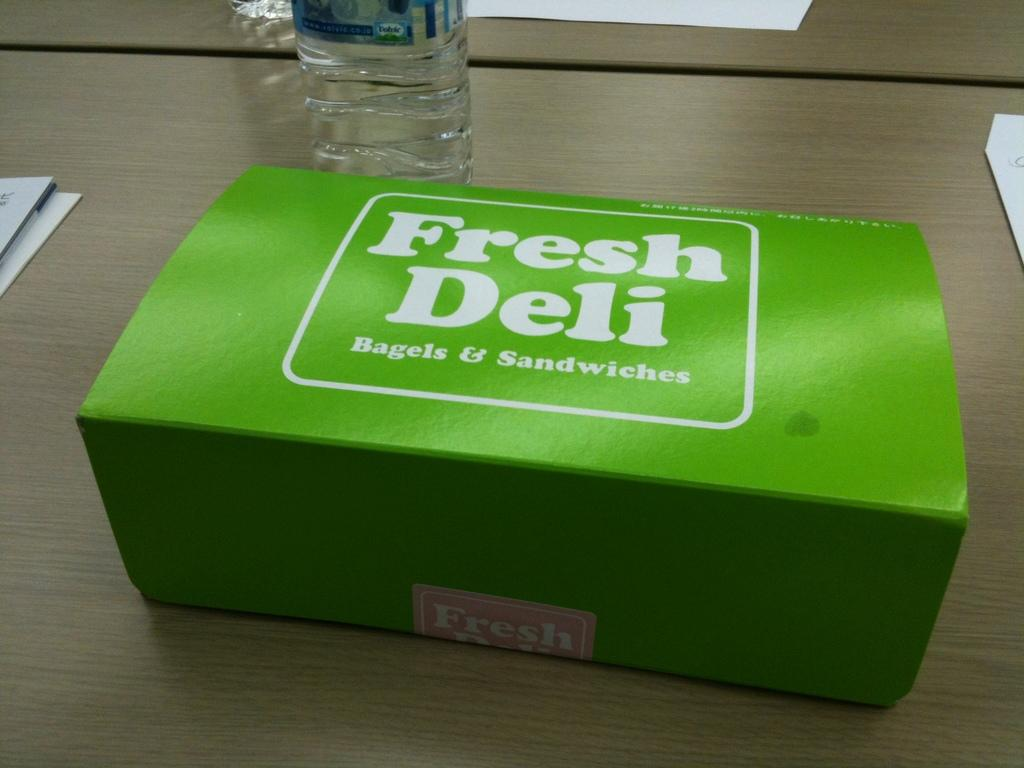<image>
Offer a succinct explanation of the picture presented. A green box with the text fresh deli is on the table. 